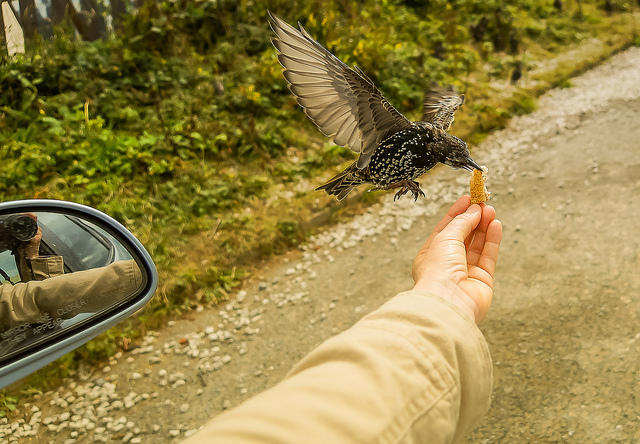Read and extract the text from this image. APPEAR 